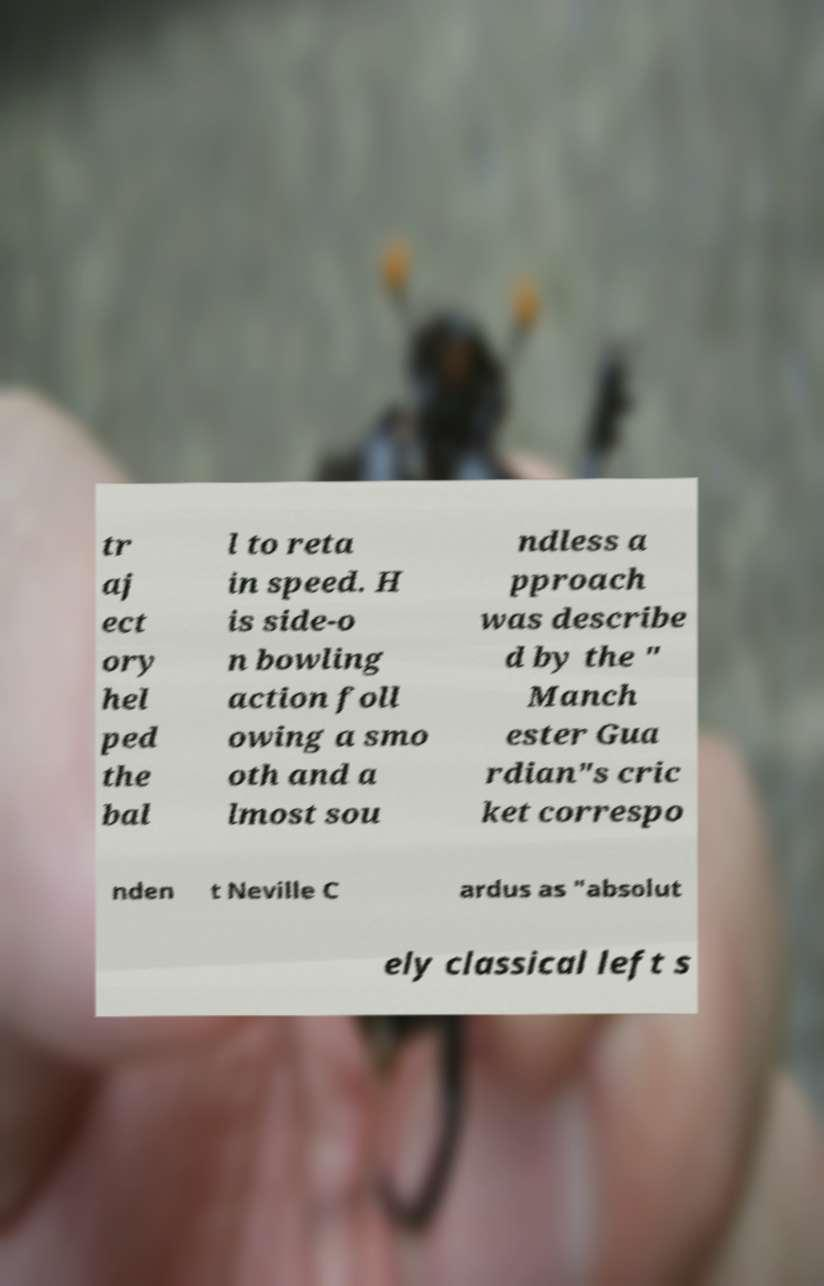What messages or text are displayed in this image? I need them in a readable, typed format. tr aj ect ory hel ped the bal l to reta in speed. H is side-o n bowling action foll owing a smo oth and a lmost sou ndless a pproach was describe d by the " Manch ester Gua rdian"s cric ket correspo nden t Neville C ardus as "absolut ely classical left s 